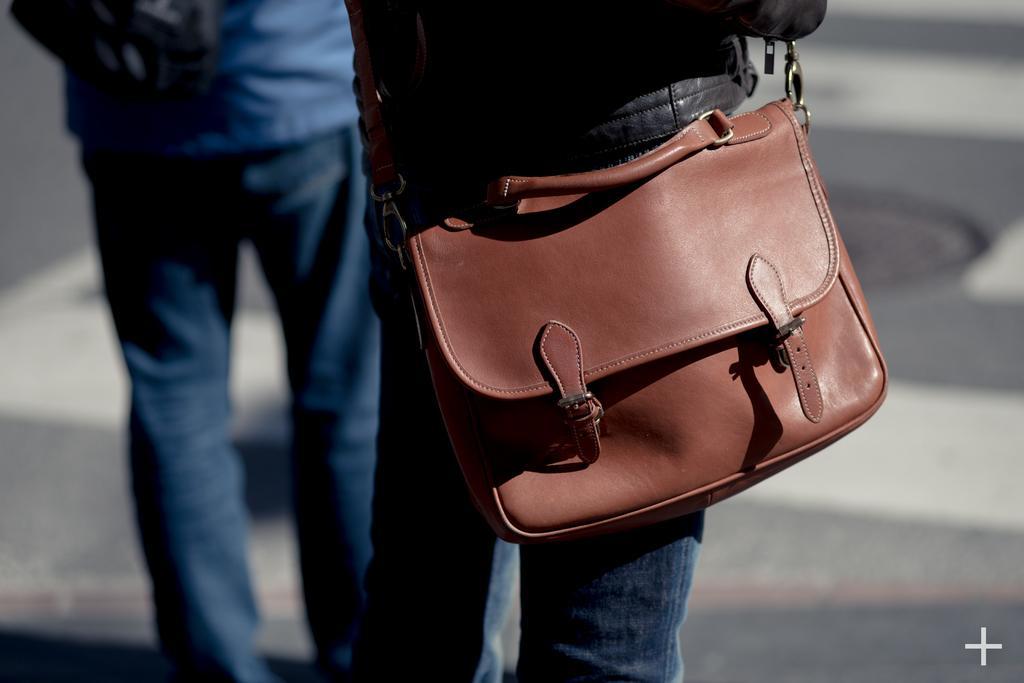Please provide a concise description of this image. In this picture we can see two persons are standing and one person is wearing a backpack. 